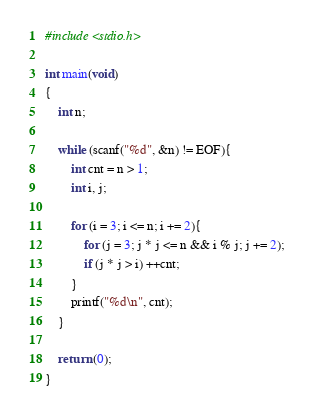Convert code to text. <code><loc_0><loc_0><loc_500><loc_500><_C_>#include <stdio.h>

int main(void)
{
    int n;

    while (scanf("%d", &n) != EOF){
        int cnt = n > 1;
        int i, j;

        for (i = 3; i <= n; i += 2){
            for (j = 3; j * j <= n && i % j; j += 2);
            if (j * j > i) ++cnt;
        }
        printf("%d\n", cnt);
    }

    return (0);
}</code> 